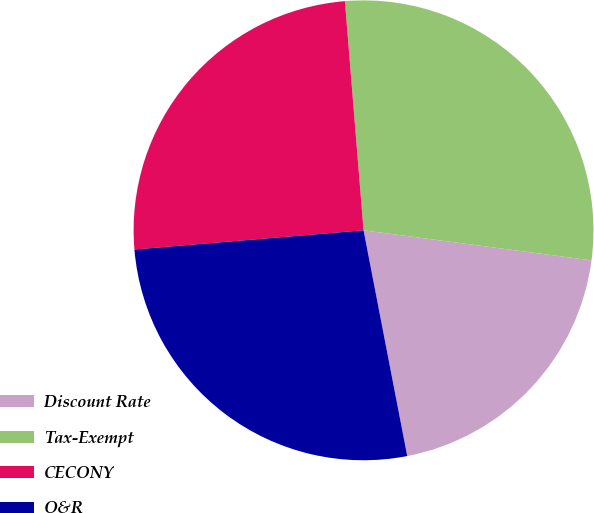<chart> <loc_0><loc_0><loc_500><loc_500><pie_chart><fcel>Discount Rate<fcel>Tax-Exempt<fcel>CECONY<fcel>O&R<nl><fcel>19.87%<fcel>28.38%<fcel>25.04%<fcel>26.71%<nl></chart> 